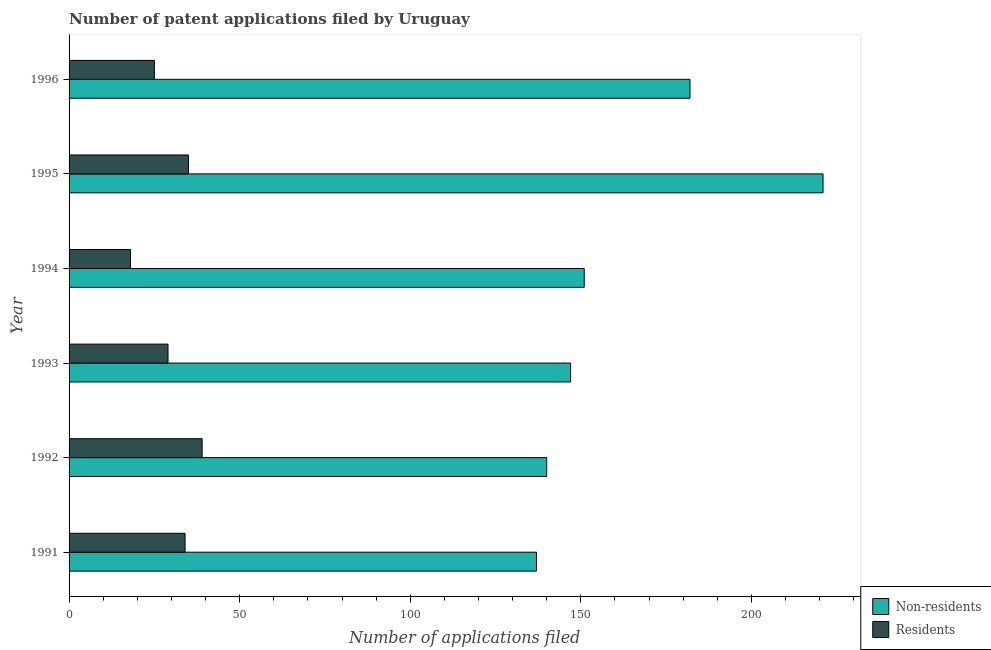How many different coloured bars are there?
Give a very brief answer. 2. How many groups of bars are there?
Your answer should be very brief. 6. Are the number of bars on each tick of the Y-axis equal?
Your answer should be very brief. Yes. How many bars are there on the 2nd tick from the top?
Your answer should be compact. 2. What is the label of the 3rd group of bars from the top?
Your answer should be very brief. 1994. What is the number of patent applications by residents in 1991?
Offer a very short reply. 34. Across all years, what is the maximum number of patent applications by residents?
Ensure brevity in your answer.  39. Across all years, what is the minimum number of patent applications by residents?
Your response must be concise. 18. In which year was the number of patent applications by residents minimum?
Your response must be concise. 1994. What is the total number of patent applications by non residents in the graph?
Your response must be concise. 978. What is the difference between the number of patent applications by residents in 1994 and that in 1996?
Provide a short and direct response. -7. What is the difference between the number of patent applications by residents in 1992 and the number of patent applications by non residents in 1996?
Make the answer very short. -143. What is the average number of patent applications by non residents per year?
Offer a terse response. 163. In the year 1992, what is the difference between the number of patent applications by residents and number of patent applications by non residents?
Ensure brevity in your answer.  -101. What is the ratio of the number of patent applications by residents in 1995 to that in 1996?
Provide a short and direct response. 1.4. Is the number of patent applications by residents in 1991 less than that in 1994?
Your answer should be very brief. No. What is the difference between the highest and the lowest number of patent applications by residents?
Provide a short and direct response. 21. What does the 1st bar from the top in 1995 represents?
Ensure brevity in your answer.  Residents. What does the 1st bar from the bottom in 1994 represents?
Provide a succinct answer. Non-residents. How many years are there in the graph?
Your response must be concise. 6. What is the difference between two consecutive major ticks on the X-axis?
Your answer should be very brief. 50. Does the graph contain any zero values?
Give a very brief answer. No. Does the graph contain grids?
Provide a short and direct response. No. Where does the legend appear in the graph?
Provide a short and direct response. Bottom right. How are the legend labels stacked?
Provide a succinct answer. Vertical. What is the title of the graph?
Ensure brevity in your answer.  Number of patent applications filed by Uruguay. Does "Females" appear as one of the legend labels in the graph?
Your answer should be very brief. No. What is the label or title of the X-axis?
Provide a succinct answer. Number of applications filed. What is the label or title of the Y-axis?
Offer a terse response. Year. What is the Number of applications filed of Non-residents in 1991?
Give a very brief answer. 137. What is the Number of applications filed in Non-residents in 1992?
Your answer should be very brief. 140. What is the Number of applications filed in Non-residents in 1993?
Offer a terse response. 147. What is the Number of applications filed in Residents in 1993?
Your answer should be compact. 29. What is the Number of applications filed of Non-residents in 1994?
Offer a very short reply. 151. What is the Number of applications filed in Non-residents in 1995?
Provide a short and direct response. 221. What is the Number of applications filed in Non-residents in 1996?
Ensure brevity in your answer.  182. What is the Number of applications filed of Residents in 1996?
Your answer should be very brief. 25. Across all years, what is the maximum Number of applications filed of Non-residents?
Make the answer very short. 221. Across all years, what is the maximum Number of applications filed of Residents?
Make the answer very short. 39. Across all years, what is the minimum Number of applications filed of Non-residents?
Your answer should be very brief. 137. What is the total Number of applications filed in Non-residents in the graph?
Make the answer very short. 978. What is the total Number of applications filed of Residents in the graph?
Your answer should be very brief. 180. What is the difference between the Number of applications filed of Non-residents in 1991 and that in 1992?
Your answer should be very brief. -3. What is the difference between the Number of applications filed in Non-residents in 1991 and that in 1993?
Your response must be concise. -10. What is the difference between the Number of applications filed in Residents in 1991 and that in 1993?
Your response must be concise. 5. What is the difference between the Number of applications filed of Non-residents in 1991 and that in 1994?
Make the answer very short. -14. What is the difference between the Number of applications filed in Non-residents in 1991 and that in 1995?
Your response must be concise. -84. What is the difference between the Number of applications filed of Non-residents in 1991 and that in 1996?
Your response must be concise. -45. What is the difference between the Number of applications filed of Residents in 1991 and that in 1996?
Give a very brief answer. 9. What is the difference between the Number of applications filed of Residents in 1992 and that in 1993?
Your answer should be compact. 10. What is the difference between the Number of applications filed in Non-residents in 1992 and that in 1994?
Give a very brief answer. -11. What is the difference between the Number of applications filed of Non-residents in 1992 and that in 1995?
Provide a succinct answer. -81. What is the difference between the Number of applications filed in Residents in 1992 and that in 1995?
Ensure brevity in your answer.  4. What is the difference between the Number of applications filed in Non-residents in 1992 and that in 1996?
Give a very brief answer. -42. What is the difference between the Number of applications filed in Residents in 1992 and that in 1996?
Offer a terse response. 14. What is the difference between the Number of applications filed of Residents in 1993 and that in 1994?
Give a very brief answer. 11. What is the difference between the Number of applications filed in Non-residents in 1993 and that in 1995?
Provide a short and direct response. -74. What is the difference between the Number of applications filed of Non-residents in 1993 and that in 1996?
Give a very brief answer. -35. What is the difference between the Number of applications filed in Residents in 1993 and that in 1996?
Provide a succinct answer. 4. What is the difference between the Number of applications filed of Non-residents in 1994 and that in 1995?
Your answer should be very brief. -70. What is the difference between the Number of applications filed of Non-residents in 1994 and that in 1996?
Give a very brief answer. -31. What is the difference between the Number of applications filed in Non-residents in 1995 and that in 1996?
Offer a terse response. 39. What is the difference between the Number of applications filed in Non-residents in 1991 and the Number of applications filed in Residents in 1993?
Your answer should be compact. 108. What is the difference between the Number of applications filed in Non-residents in 1991 and the Number of applications filed in Residents in 1994?
Your answer should be very brief. 119. What is the difference between the Number of applications filed in Non-residents in 1991 and the Number of applications filed in Residents in 1995?
Offer a terse response. 102. What is the difference between the Number of applications filed in Non-residents in 1991 and the Number of applications filed in Residents in 1996?
Your answer should be very brief. 112. What is the difference between the Number of applications filed in Non-residents in 1992 and the Number of applications filed in Residents in 1993?
Offer a very short reply. 111. What is the difference between the Number of applications filed in Non-residents in 1992 and the Number of applications filed in Residents in 1994?
Offer a terse response. 122. What is the difference between the Number of applications filed in Non-residents in 1992 and the Number of applications filed in Residents in 1995?
Offer a terse response. 105. What is the difference between the Number of applications filed in Non-residents in 1992 and the Number of applications filed in Residents in 1996?
Provide a succinct answer. 115. What is the difference between the Number of applications filed in Non-residents in 1993 and the Number of applications filed in Residents in 1994?
Ensure brevity in your answer.  129. What is the difference between the Number of applications filed in Non-residents in 1993 and the Number of applications filed in Residents in 1995?
Give a very brief answer. 112. What is the difference between the Number of applications filed of Non-residents in 1993 and the Number of applications filed of Residents in 1996?
Your answer should be compact. 122. What is the difference between the Number of applications filed of Non-residents in 1994 and the Number of applications filed of Residents in 1995?
Offer a terse response. 116. What is the difference between the Number of applications filed of Non-residents in 1994 and the Number of applications filed of Residents in 1996?
Give a very brief answer. 126. What is the difference between the Number of applications filed in Non-residents in 1995 and the Number of applications filed in Residents in 1996?
Offer a very short reply. 196. What is the average Number of applications filed of Non-residents per year?
Your answer should be very brief. 163. What is the average Number of applications filed in Residents per year?
Ensure brevity in your answer.  30. In the year 1991, what is the difference between the Number of applications filed of Non-residents and Number of applications filed of Residents?
Offer a very short reply. 103. In the year 1992, what is the difference between the Number of applications filed of Non-residents and Number of applications filed of Residents?
Offer a very short reply. 101. In the year 1993, what is the difference between the Number of applications filed of Non-residents and Number of applications filed of Residents?
Your response must be concise. 118. In the year 1994, what is the difference between the Number of applications filed in Non-residents and Number of applications filed in Residents?
Provide a succinct answer. 133. In the year 1995, what is the difference between the Number of applications filed of Non-residents and Number of applications filed of Residents?
Your answer should be compact. 186. In the year 1996, what is the difference between the Number of applications filed of Non-residents and Number of applications filed of Residents?
Keep it short and to the point. 157. What is the ratio of the Number of applications filed of Non-residents in 1991 to that in 1992?
Provide a short and direct response. 0.98. What is the ratio of the Number of applications filed in Residents in 1991 to that in 1992?
Provide a succinct answer. 0.87. What is the ratio of the Number of applications filed of Non-residents in 1991 to that in 1993?
Provide a short and direct response. 0.93. What is the ratio of the Number of applications filed in Residents in 1991 to that in 1993?
Give a very brief answer. 1.17. What is the ratio of the Number of applications filed of Non-residents in 1991 to that in 1994?
Offer a very short reply. 0.91. What is the ratio of the Number of applications filed of Residents in 1991 to that in 1994?
Your response must be concise. 1.89. What is the ratio of the Number of applications filed in Non-residents in 1991 to that in 1995?
Keep it short and to the point. 0.62. What is the ratio of the Number of applications filed of Residents in 1991 to that in 1995?
Keep it short and to the point. 0.97. What is the ratio of the Number of applications filed in Non-residents in 1991 to that in 1996?
Your answer should be very brief. 0.75. What is the ratio of the Number of applications filed of Residents in 1991 to that in 1996?
Your answer should be very brief. 1.36. What is the ratio of the Number of applications filed in Non-residents in 1992 to that in 1993?
Provide a succinct answer. 0.95. What is the ratio of the Number of applications filed in Residents in 1992 to that in 1993?
Your response must be concise. 1.34. What is the ratio of the Number of applications filed in Non-residents in 1992 to that in 1994?
Keep it short and to the point. 0.93. What is the ratio of the Number of applications filed in Residents in 1992 to that in 1994?
Your answer should be compact. 2.17. What is the ratio of the Number of applications filed of Non-residents in 1992 to that in 1995?
Your answer should be compact. 0.63. What is the ratio of the Number of applications filed in Residents in 1992 to that in 1995?
Provide a short and direct response. 1.11. What is the ratio of the Number of applications filed of Non-residents in 1992 to that in 1996?
Your answer should be very brief. 0.77. What is the ratio of the Number of applications filed in Residents in 1992 to that in 1996?
Offer a very short reply. 1.56. What is the ratio of the Number of applications filed in Non-residents in 1993 to that in 1994?
Provide a short and direct response. 0.97. What is the ratio of the Number of applications filed in Residents in 1993 to that in 1994?
Keep it short and to the point. 1.61. What is the ratio of the Number of applications filed in Non-residents in 1993 to that in 1995?
Offer a very short reply. 0.67. What is the ratio of the Number of applications filed in Residents in 1993 to that in 1995?
Give a very brief answer. 0.83. What is the ratio of the Number of applications filed of Non-residents in 1993 to that in 1996?
Keep it short and to the point. 0.81. What is the ratio of the Number of applications filed in Residents in 1993 to that in 1996?
Provide a succinct answer. 1.16. What is the ratio of the Number of applications filed in Non-residents in 1994 to that in 1995?
Your answer should be compact. 0.68. What is the ratio of the Number of applications filed in Residents in 1994 to that in 1995?
Your answer should be very brief. 0.51. What is the ratio of the Number of applications filed in Non-residents in 1994 to that in 1996?
Your response must be concise. 0.83. What is the ratio of the Number of applications filed in Residents in 1994 to that in 1996?
Offer a very short reply. 0.72. What is the ratio of the Number of applications filed of Non-residents in 1995 to that in 1996?
Make the answer very short. 1.21. What is the difference between the highest and the second highest Number of applications filed of Residents?
Ensure brevity in your answer.  4. What is the difference between the highest and the lowest Number of applications filed in Non-residents?
Offer a very short reply. 84. 